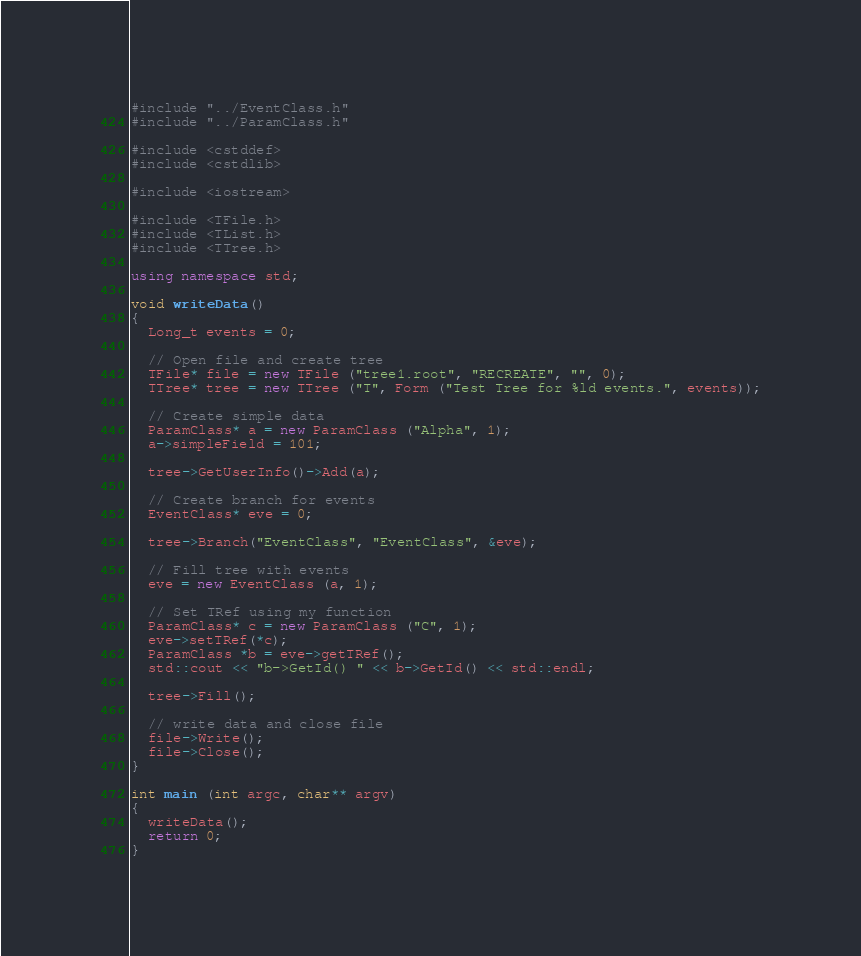Convert code to text. <code><loc_0><loc_0><loc_500><loc_500><_C++_>#include "../EventClass.h"
#include "../ParamClass.h"

#include <cstddef>
#include <cstdlib>

#include <iostream>

#include <TFile.h>
#include <TList.h>
#include <TTree.h>

using namespace std;

void writeData()
{
  Long_t events = 0;

  // Open file and create tree
  TFile* file = new TFile ("tree1.root", "RECREATE", "", 0);
  TTree* tree = new TTree ("T", Form ("Test Tree for %ld events.", events));

  // Create simple data
  ParamClass* a = new ParamClass ("Alpha", 1);
  a->simpleField = 101;

  tree->GetUserInfo()->Add(a);

  // Create branch for events
  EventClass* eve = 0;

  tree->Branch("EventClass", "EventClass", &eve);
  
  // Fill tree with events
  eve = new EventClass (a, 1);
  
  // Set TRef using my function
  ParamClass* c = new ParamClass ("C", 1);
  eve->setTRef(*c);
  ParamClass *b = eve->getTRef();
  std::cout << "b->GetId() " << b->GetId() << std::endl;

  tree->Fill();

  // write data and close file
  file->Write();
  file->Close();
}

int main (int argc, char** argv) 
{
  writeData();
  return 0;
}
</code> 